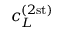<formula> <loc_0><loc_0><loc_500><loc_500>c _ { L } ^ { ( 2 s t ) }</formula> 